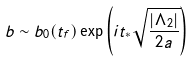<formula> <loc_0><loc_0><loc_500><loc_500>b \sim b _ { 0 } ( t _ { f } ) \exp \left ( i t _ { * } \sqrt { \frac { | \Lambda _ { 2 } | } { 2 a } } \right )</formula> 